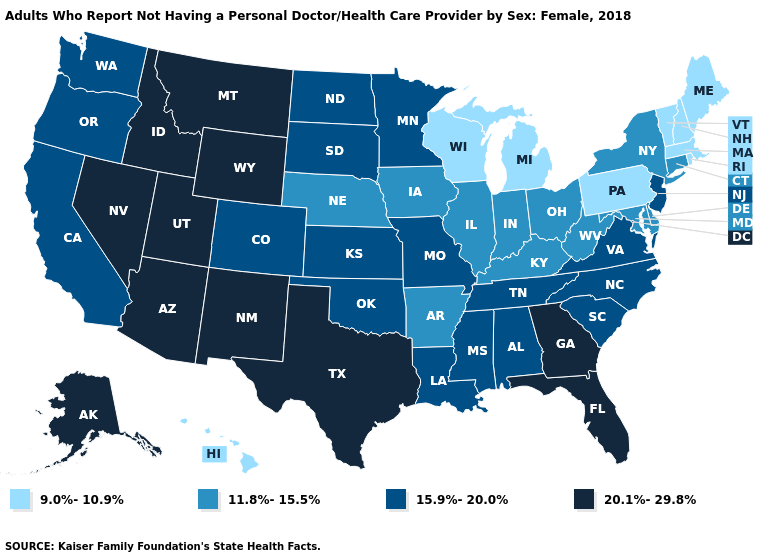Does New Jersey have a higher value than Utah?
Be succinct. No. What is the value of Arizona?
Be succinct. 20.1%-29.8%. What is the value of Montana?
Answer briefly. 20.1%-29.8%. What is the lowest value in the MidWest?
Be succinct. 9.0%-10.9%. Does Arizona have the highest value in the USA?
Answer briefly. Yes. What is the highest value in the USA?
Concise answer only. 20.1%-29.8%. Does Indiana have a lower value than North Carolina?
Short answer required. Yes. Does the map have missing data?
Give a very brief answer. No. Name the states that have a value in the range 9.0%-10.9%?
Concise answer only. Hawaii, Maine, Massachusetts, Michigan, New Hampshire, Pennsylvania, Rhode Island, Vermont, Wisconsin. Which states have the lowest value in the USA?
Short answer required. Hawaii, Maine, Massachusetts, Michigan, New Hampshire, Pennsylvania, Rhode Island, Vermont, Wisconsin. What is the value of Wisconsin?
Write a very short answer. 9.0%-10.9%. Which states hav the highest value in the South?
Short answer required. Florida, Georgia, Texas. What is the value of Montana?
Concise answer only. 20.1%-29.8%. Name the states that have a value in the range 9.0%-10.9%?
Keep it brief. Hawaii, Maine, Massachusetts, Michigan, New Hampshire, Pennsylvania, Rhode Island, Vermont, Wisconsin. Is the legend a continuous bar?
Answer briefly. No. 